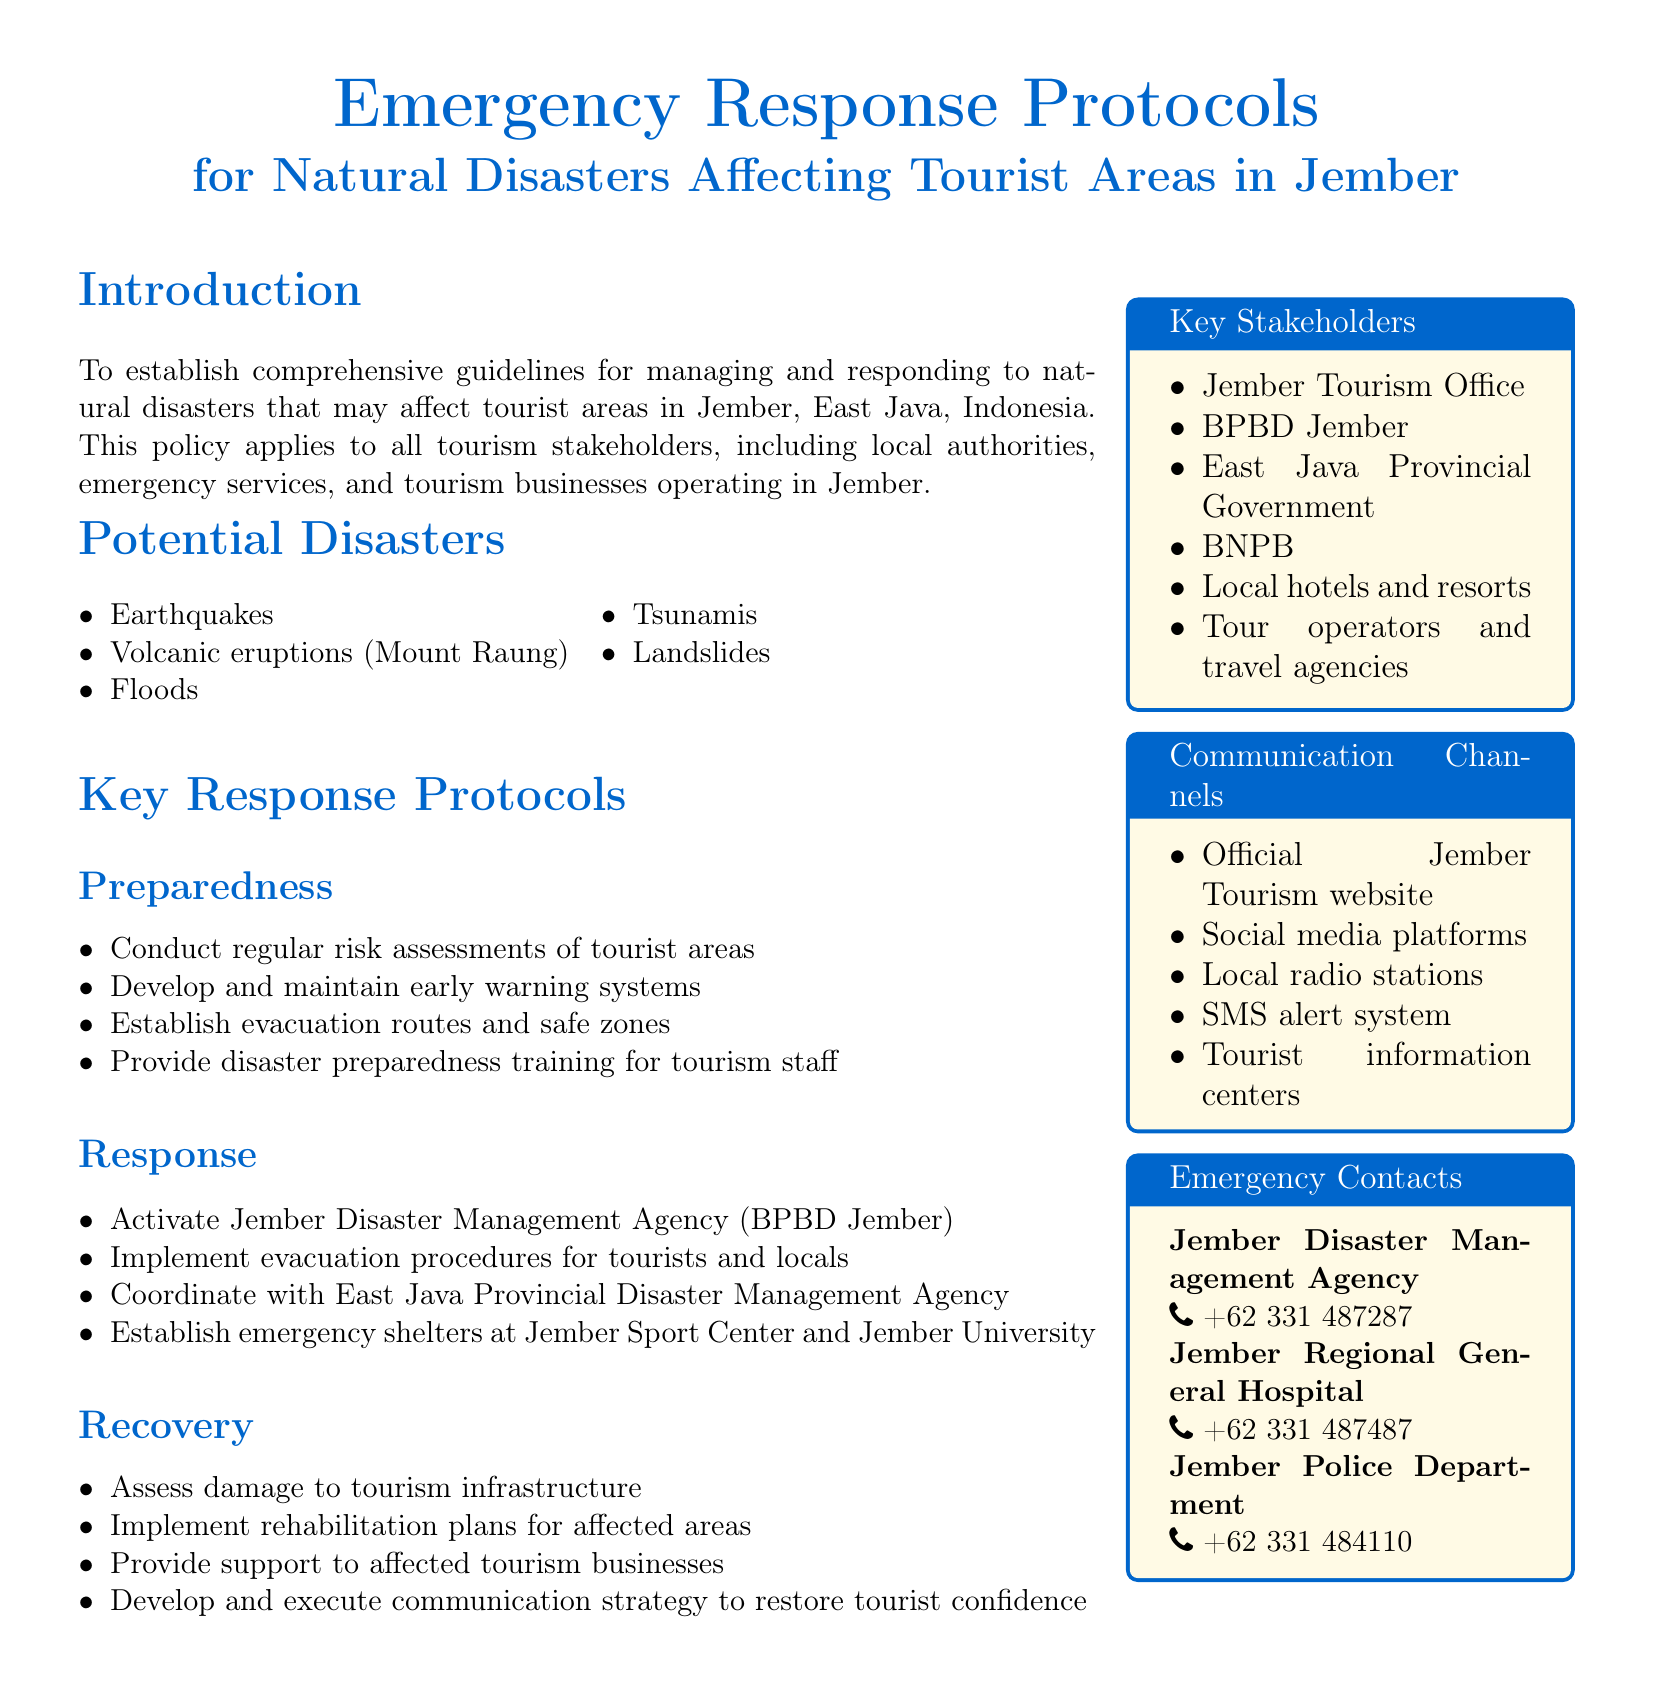What is the title of the document? The title clearly states the main subject and focus of the document regarding emergency protocols for tourism.
Answer: Emergency Response Protocols for Natural Disasters Affecting Tourist Areas in Jember What are the types of potential disasters mentioned? The document lists several types of disasters that could affect tourism in Jember; these include natural calamities that require response protocols.
Answer: Earthquakes, volcanic eruptions, floods, tsunamis, landslides How often should risk assessments be conducted according to the preparedness protocols? The document mentions regularity in conducting risk assessments, indicating an ongoing responsibility.
Answer: Regularly What are the emergency shelter locations stated in the document? The document specifies two areas for emergency shelters designated for disaster responses in Jember.
Answer: Jember Sport Center, Jember University Which agency is activated during a disaster response? The document identifies the local agency mandated to respond to disasters, crucial for coordination and action.
Answer: Jember Disaster Management Agency (BPBD Jember) How many key stakeholders are listed in the document? The document presents a list of parties involved in tourism and disaster response, indicating collaboration.
Answer: Six What is the official contact phone number for Jember Police Department? The document provides specific contact information crucial for immediate assistance during emergencies.
Answer: +62 331 484110 What communication channels are suggested for emergency updates? The document lays out several channels through which information can be disseminated, important for public awareness during emergencies.
Answer: Official Jember Tourism website, social media platforms, local radio stations, SMS alert system, tourist information centers What is the primary purpose of the document? The introduction outlines the fundamental goal of establishing guidelines to manage and respond effectively to disasters impacting tourism.
Answer: To establish comprehensive guidelines for managing and responding to natural disasters 